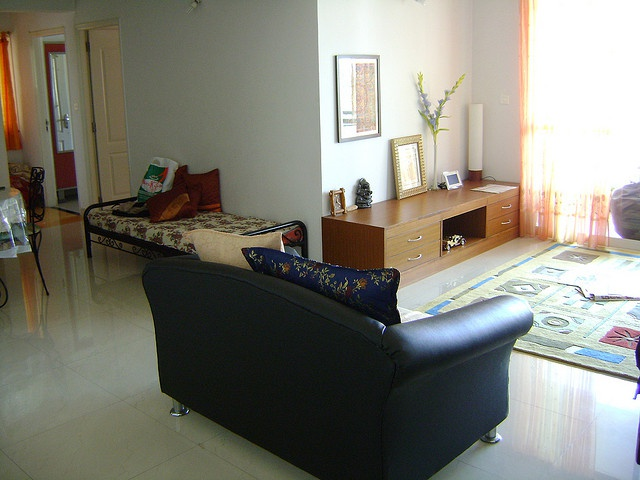Describe the objects in this image and their specific colors. I can see couch in darkgreen, black, gray, and blue tones, bed in darkgreen, black, gray, and maroon tones, dining table in darkgreen, gray, darkgray, and black tones, couch in darkgreen, gray, and darkgray tones, and chair in darkgreen, black, maroon, and gray tones in this image. 